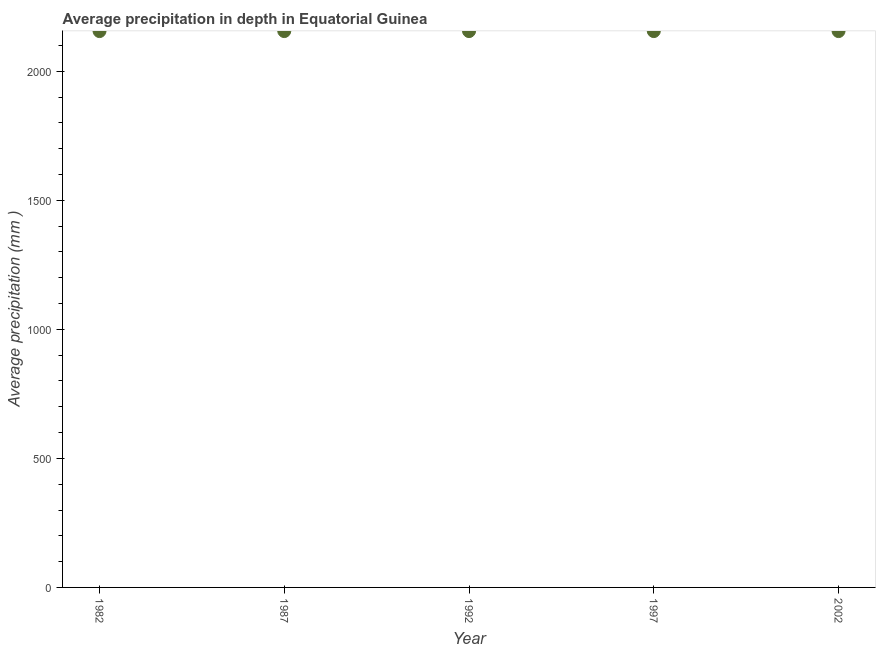What is the average precipitation in depth in 2002?
Your response must be concise. 2156. Across all years, what is the maximum average precipitation in depth?
Give a very brief answer. 2156. Across all years, what is the minimum average precipitation in depth?
Your answer should be compact. 2156. In which year was the average precipitation in depth maximum?
Provide a succinct answer. 1982. In which year was the average precipitation in depth minimum?
Keep it short and to the point. 1982. What is the sum of the average precipitation in depth?
Ensure brevity in your answer.  1.08e+04. What is the average average precipitation in depth per year?
Provide a succinct answer. 2156. What is the median average precipitation in depth?
Your answer should be compact. 2156. In how many years, is the average precipitation in depth greater than 600 mm?
Provide a short and direct response. 5. Do a majority of the years between 1997 and 2002 (inclusive) have average precipitation in depth greater than 500 mm?
Your response must be concise. Yes. What is the ratio of the average precipitation in depth in 1987 to that in 2002?
Your answer should be compact. 1. Is the difference between the average precipitation in depth in 1987 and 1997 greater than the difference between any two years?
Your answer should be very brief. Yes. What is the difference between the highest and the lowest average precipitation in depth?
Keep it short and to the point. 0. In how many years, is the average precipitation in depth greater than the average average precipitation in depth taken over all years?
Ensure brevity in your answer.  0. Does the average precipitation in depth monotonically increase over the years?
Make the answer very short. No. How many dotlines are there?
Ensure brevity in your answer.  1. What is the difference between two consecutive major ticks on the Y-axis?
Your response must be concise. 500. Are the values on the major ticks of Y-axis written in scientific E-notation?
Offer a terse response. No. Does the graph contain grids?
Keep it short and to the point. No. What is the title of the graph?
Give a very brief answer. Average precipitation in depth in Equatorial Guinea. What is the label or title of the Y-axis?
Your answer should be very brief. Average precipitation (mm ). What is the Average precipitation (mm ) in 1982?
Your response must be concise. 2156. What is the Average precipitation (mm ) in 1987?
Give a very brief answer. 2156. What is the Average precipitation (mm ) in 1992?
Offer a terse response. 2156. What is the Average precipitation (mm ) in 1997?
Make the answer very short. 2156. What is the Average precipitation (mm ) in 2002?
Give a very brief answer. 2156. What is the difference between the Average precipitation (mm ) in 1982 and 1992?
Keep it short and to the point. 0. What is the difference between the Average precipitation (mm ) in 1982 and 1997?
Your answer should be compact. 0. What is the difference between the Average precipitation (mm ) in 1987 and 1997?
Provide a succinct answer. 0. What is the difference between the Average precipitation (mm ) in 1987 and 2002?
Your answer should be very brief. 0. What is the difference between the Average precipitation (mm ) in 1992 and 2002?
Offer a very short reply. 0. What is the difference between the Average precipitation (mm ) in 1997 and 2002?
Give a very brief answer. 0. What is the ratio of the Average precipitation (mm ) in 1982 to that in 1997?
Offer a very short reply. 1. What is the ratio of the Average precipitation (mm ) in 1982 to that in 2002?
Make the answer very short. 1. What is the ratio of the Average precipitation (mm ) in 1987 to that in 1992?
Offer a very short reply. 1. What is the ratio of the Average precipitation (mm ) in 1987 to that in 1997?
Your answer should be very brief. 1. What is the ratio of the Average precipitation (mm ) in 1992 to that in 1997?
Your answer should be very brief. 1. 